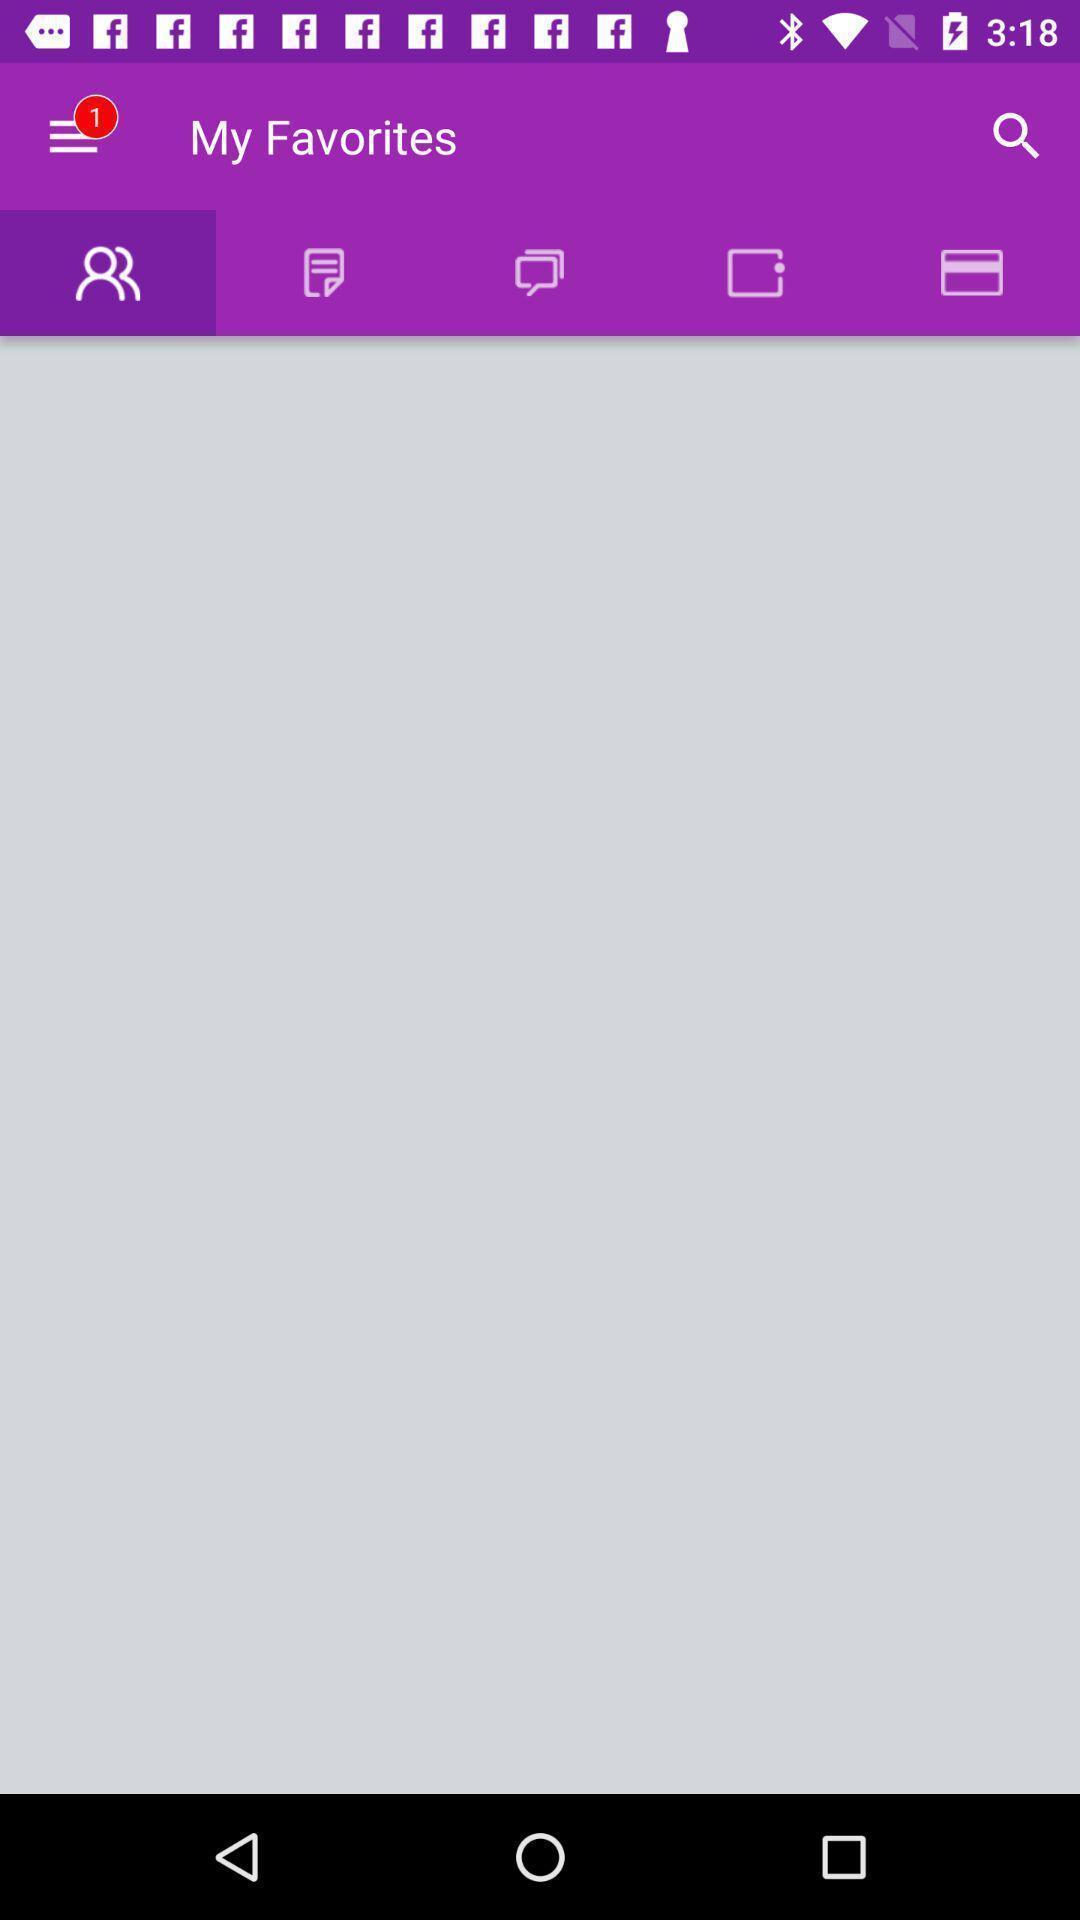Describe this image in words. Screen showing my favorites with options. 